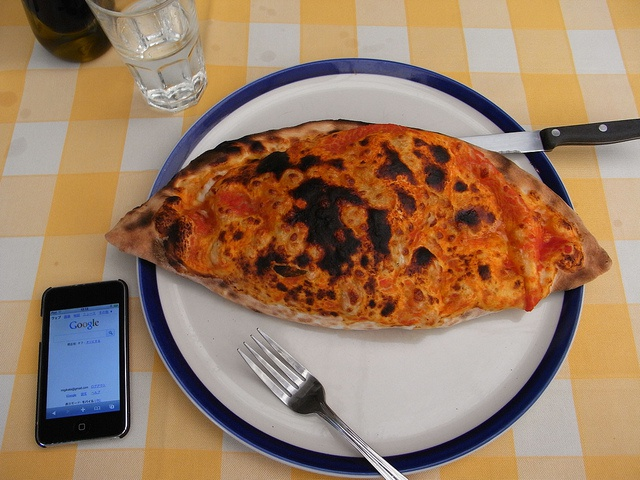Describe the objects in this image and their specific colors. I can see dining table in olive, tan, and darkgray tones, pizza in olive, brown, maroon, and black tones, cell phone in olive, black, gray, and blue tones, cup in olive, darkgray, gray, and tan tones, and fork in olive, darkgray, gray, black, and lightgray tones in this image. 